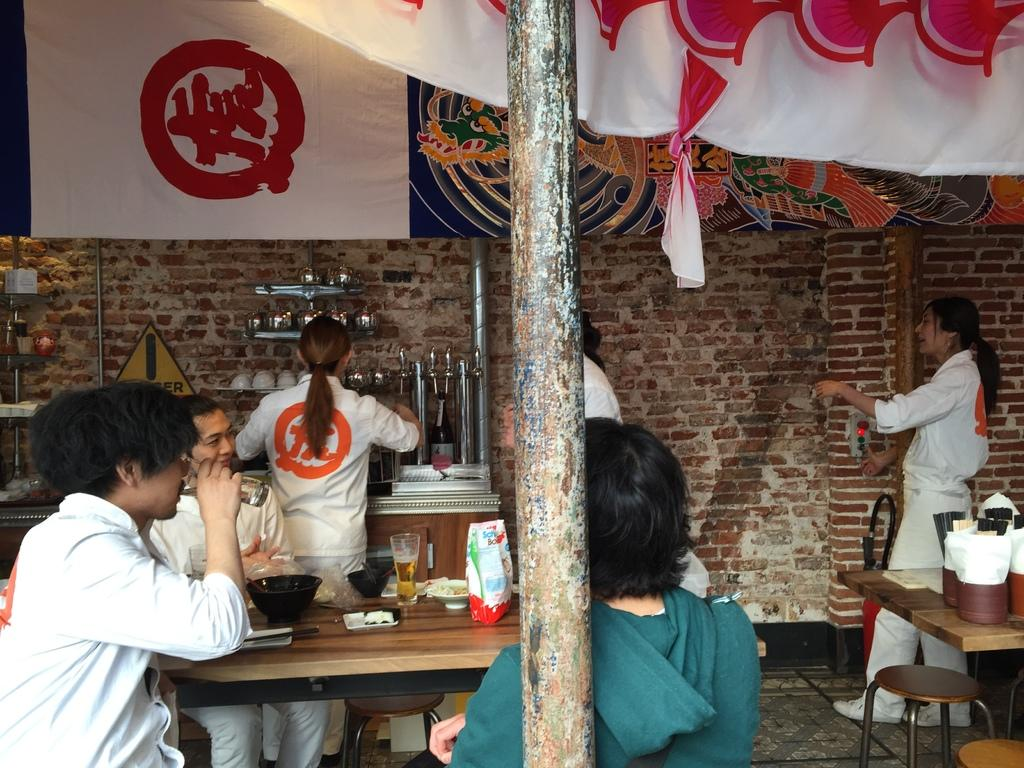How many people are in the image? There is a group of people in the image. What are the people doing in the image? The people are having a meal. What are the seated people using to support themselves? The people are sitting on chairs. What is in front of the seated people? There is a table in front of the seated people. Are there any people standing in the image? Yes, some people are standing in the image. What type of lace is being used to decorate the babies' clothing in the image? There are no babies or lace present in the image; it features a group of people having a meal. 